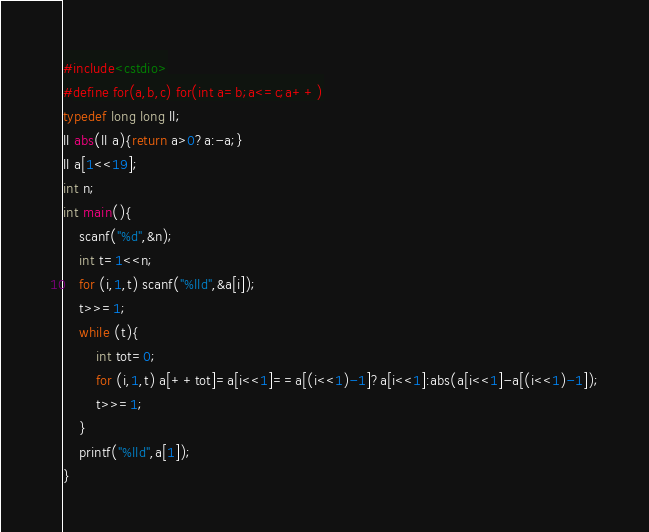<code> <loc_0><loc_0><loc_500><loc_500><_C++_>#include<cstdio>
#define for(a,b,c) for(int a=b;a<=c;a++)
typedef long long ll;
ll abs(ll a){return a>0?a:-a;}
ll a[1<<19];
int n;
int main(){
	scanf("%d",&n);
	int t=1<<n;
	for (i,1,t) scanf("%lld",&a[i]);
	t>>=1;
	while (t){
		int tot=0;
		for (i,1,t) a[++tot]=a[i<<1]==a[(i<<1)-1]?a[i<<1]:abs(a[i<<1]-a[(i<<1)-1]);
		t>>=1;
	}
	printf("%lld",a[1]);
}</code> 